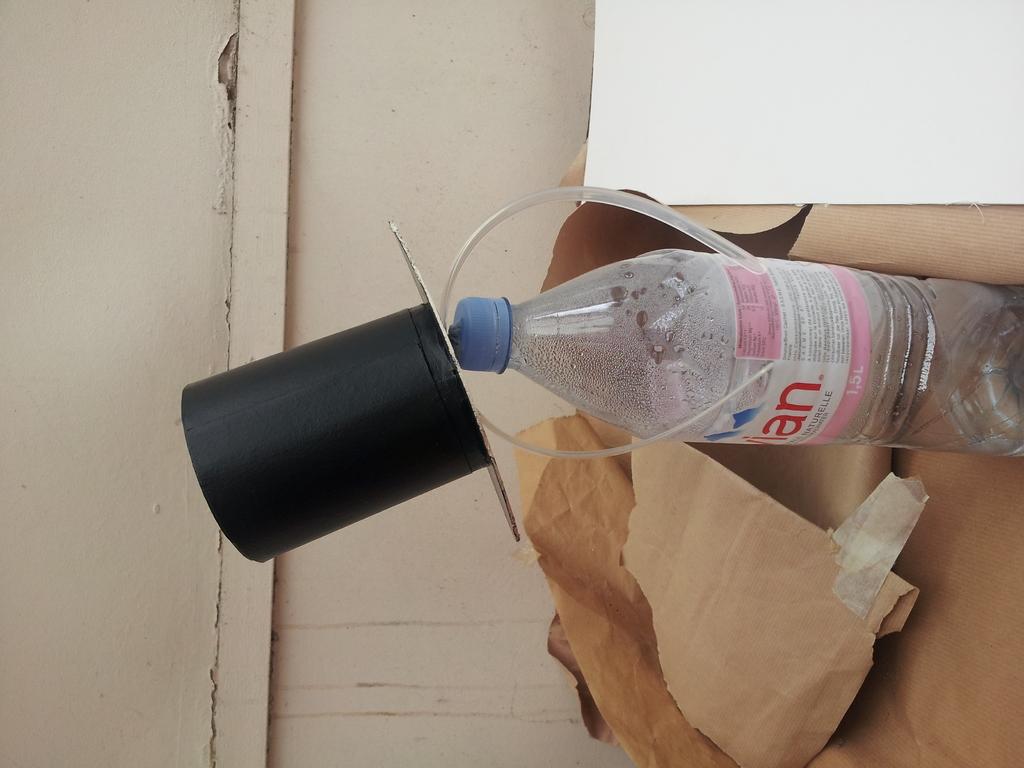Who made that water?
Your answer should be compact. Evian. 